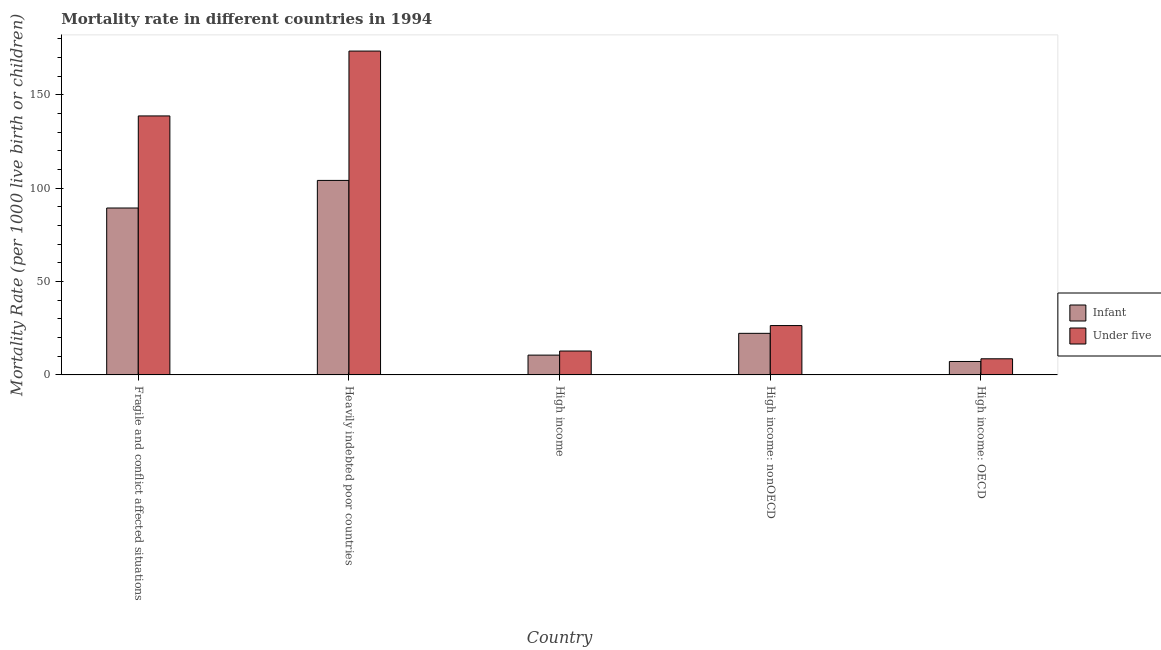How many different coloured bars are there?
Your answer should be very brief. 2. How many groups of bars are there?
Ensure brevity in your answer.  5. How many bars are there on the 2nd tick from the left?
Your answer should be very brief. 2. What is the label of the 3rd group of bars from the left?
Offer a very short reply. High income. What is the infant mortality rate in Fragile and conflict affected situations?
Provide a succinct answer. 89.4. Across all countries, what is the maximum infant mortality rate?
Keep it short and to the point. 104.19. Across all countries, what is the minimum under-5 mortality rate?
Provide a succinct answer. 8.63. In which country was the infant mortality rate maximum?
Keep it short and to the point. Heavily indebted poor countries. In which country was the under-5 mortality rate minimum?
Make the answer very short. High income: OECD. What is the total infant mortality rate in the graph?
Your response must be concise. 233.66. What is the difference between the infant mortality rate in Fragile and conflict affected situations and that in Heavily indebted poor countries?
Make the answer very short. -14.78. What is the difference between the infant mortality rate in High income: OECD and the under-5 mortality rate in High income?
Give a very brief answer. -5.61. What is the average infant mortality rate per country?
Offer a terse response. 46.73. What is the difference between the under-5 mortality rate and infant mortality rate in High income: OECD?
Your answer should be very brief. 1.44. In how many countries, is the under-5 mortality rate greater than 80 ?
Keep it short and to the point. 2. What is the ratio of the under-5 mortality rate in High income: OECD to that in High income: nonOECD?
Your answer should be very brief. 0.33. What is the difference between the highest and the second highest infant mortality rate?
Offer a terse response. 14.78. What is the difference between the highest and the lowest under-5 mortality rate?
Your answer should be very brief. 164.84. In how many countries, is the infant mortality rate greater than the average infant mortality rate taken over all countries?
Provide a succinct answer. 2. Is the sum of the infant mortality rate in Fragile and conflict affected situations and High income greater than the maximum under-5 mortality rate across all countries?
Your response must be concise. No. What does the 2nd bar from the left in High income: OECD represents?
Give a very brief answer. Under five. What does the 1st bar from the right in High income represents?
Provide a short and direct response. Under five. How many bars are there?
Give a very brief answer. 10. Are all the bars in the graph horizontal?
Your response must be concise. No. What is the difference between two consecutive major ticks on the Y-axis?
Your response must be concise. 50. Are the values on the major ticks of Y-axis written in scientific E-notation?
Your answer should be compact. No. Does the graph contain any zero values?
Your answer should be compact. No. Does the graph contain grids?
Provide a succinct answer. No. Where does the legend appear in the graph?
Make the answer very short. Center right. How many legend labels are there?
Your answer should be compact. 2. What is the title of the graph?
Provide a short and direct response. Mortality rate in different countries in 1994. What is the label or title of the X-axis?
Keep it short and to the point. Country. What is the label or title of the Y-axis?
Your response must be concise. Mortality Rate (per 1000 live birth or children). What is the Mortality Rate (per 1000 live birth or children) in Infant in Fragile and conflict affected situations?
Keep it short and to the point. 89.4. What is the Mortality Rate (per 1000 live birth or children) of Under five in Fragile and conflict affected situations?
Make the answer very short. 138.73. What is the Mortality Rate (per 1000 live birth or children) in Infant in Heavily indebted poor countries?
Provide a succinct answer. 104.19. What is the Mortality Rate (per 1000 live birth or children) of Under five in Heavily indebted poor countries?
Your answer should be very brief. 173.48. What is the Mortality Rate (per 1000 live birth or children) in Infant in High income: nonOECD?
Offer a terse response. 22.27. What is the Mortality Rate (per 1000 live birth or children) of Under five in High income: nonOECD?
Offer a very short reply. 26.43. What is the Mortality Rate (per 1000 live birth or children) of Infant in High income: OECD?
Offer a terse response. 7.19. What is the Mortality Rate (per 1000 live birth or children) in Under five in High income: OECD?
Keep it short and to the point. 8.63. Across all countries, what is the maximum Mortality Rate (per 1000 live birth or children) of Infant?
Your answer should be compact. 104.19. Across all countries, what is the maximum Mortality Rate (per 1000 live birth or children) of Under five?
Your answer should be compact. 173.48. Across all countries, what is the minimum Mortality Rate (per 1000 live birth or children) of Infant?
Your answer should be compact. 7.19. Across all countries, what is the minimum Mortality Rate (per 1000 live birth or children) of Under five?
Keep it short and to the point. 8.63. What is the total Mortality Rate (per 1000 live birth or children) in Infant in the graph?
Offer a terse response. 233.66. What is the total Mortality Rate (per 1000 live birth or children) of Under five in the graph?
Ensure brevity in your answer.  360.07. What is the difference between the Mortality Rate (per 1000 live birth or children) of Infant in Fragile and conflict affected situations and that in Heavily indebted poor countries?
Provide a short and direct response. -14.78. What is the difference between the Mortality Rate (per 1000 live birth or children) of Under five in Fragile and conflict affected situations and that in Heavily indebted poor countries?
Your response must be concise. -34.75. What is the difference between the Mortality Rate (per 1000 live birth or children) in Infant in Fragile and conflict affected situations and that in High income?
Provide a succinct answer. 78.8. What is the difference between the Mortality Rate (per 1000 live birth or children) of Under five in Fragile and conflict affected situations and that in High income?
Ensure brevity in your answer.  125.93. What is the difference between the Mortality Rate (per 1000 live birth or children) in Infant in Fragile and conflict affected situations and that in High income: nonOECD?
Your response must be concise. 67.13. What is the difference between the Mortality Rate (per 1000 live birth or children) in Under five in Fragile and conflict affected situations and that in High income: nonOECD?
Your response must be concise. 112.3. What is the difference between the Mortality Rate (per 1000 live birth or children) in Infant in Fragile and conflict affected situations and that in High income: OECD?
Provide a short and direct response. 82.21. What is the difference between the Mortality Rate (per 1000 live birth or children) of Under five in Fragile and conflict affected situations and that in High income: OECD?
Your response must be concise. 130.09. What is the difference between the Mortality Rate (per 1000 live birth or children) in Infant in Heavily indebted poor countries and that in High income?
Your answer should be very brief. 93.59. What is the difference between the Mortality Rate (per 1000 live birth or children) of Under five in Heavily indebted poor countries and that in High income?
Ensure brevity in your answer.  160.68. What is the difference between the Mortality Rate (per 1000 live birth or children) in Infant in Heavily indebted poor countries and that in High income: nonOECD?
Keep it short and to the point. 81.92. What is the difference between the Mortality Rate (per 1000 live birth or children) in Under five in Heavily indebted poor countries and that in High income: nonOECD?
Offer a terse response. 147.05. What is the difference between the Mortality Rate (per 1000 live birth or children) in Infant in Heavily indebted poor countries and that in High income: OECD?
Offer a very short reply. 96.99. What is the difference between the Mortality Rate (per 1000 live birth or children) of Under five in Heavily indebted poor countries and that in High income: OECD?
Your answer should be very brief. 164.84. What is the difference between the Mortality Rate (per 1000 live birth or children) of Infant in High income and that in High income: nonOECD?
Provide a succinct answer. -11.67. What is the difference between the Mortality Rate (per 1000 live birth or children) of Under five in High income and that in High income: nonOECD?
Provide a short and direct response. -13.63. What is the difference between the Mortality Rate (per 1000 live birth or children) of Infant in High income and that in High income: OECD?
Provide a succinct answer. 3.41. What is the difference between the Mortality Rate (per 1000 live birth or children) in Under five in High income and that in High income: OECD?
Your answer should be compact. 4.17. What is the difference between the Mortality Rate (per 1000 live birth or children) in Infant in High income: nonOECD and that in High income: OECD?
Give a very brief answer. 15.08. What is the difference between the Mortality Rate (per 1000 live birth or children) of Under five in High income: nonOECD and that in High income: OECD?
Provide a short and direct response. 17.8. What is the difference between the Mortality Rate (per 1000 live birth or children) in Infant in Fragile and conflict affected situations and the Mortality Rate (per 1000 live birth or children) in Under five in Heavily indebted poor countries?
Keep it short and to the point. -84.07. What is the difference between the Mortality Rate (per 1000 live birth or children) of Infant in Fragile and conflict affected situations and the Mortality Rate (per 1000 live birth or children) of Under five in High income?
Your answer should be very brief. 76.6. What is the difference between the Mortality Rate (per 1000 live birth or children) in Infant in Fragile and conflict affected situations and the Mortality Rate (per 1000 live birth or children) in Under five in High income: nonOECD?
Keep it short and to the point. 62.97. What is the difference between the Mortality Rate (per 1000 live birth or children) of Infant in Fragile and conflict affected situations and the Mortality Rate (per 1000 live birth or children) of Under five in High income: OECD?
Your response must be concise. 80.77. What is the difference between the Mortality Rate (per 1000 live birth or children) in Infant in Heavily indebted poor countries and the Mortality Rate (per 1000 live birth or children) in Under five in High income?
Your answer should be compact. 91.39. What is the difference between the Mortality Rate (per 1000 live birth or children) of Infant in Heavily indebted poor countries and the Mortality Rate (per 1000 live birth or children) of Under five in High income: nonOECD?
Make the answer very short. 77.76. What is the difference between the Mortality Rate (per 1000 live birth or children) in Infant in Heavily indebted poor countries and the Mortality Rate (per 1000 live birth or children) in Under five in High income: OECD?
Make the answer very short. 95.55. What is the difference between the Mortality Rate (per 1000 live birth or children) of Infant in High income and the Mortality Rate (per 1000 live birth or children) of Under five in High income: nonOECD?
Your response must be concise. -15.83. What is the difference between the Mortality Rate (per 1000 live birth or children) of Infant in High income and the Mortality Rate (per 1000 live birth or children) of Under five in High income: OECD?
Your response must be concise. 1.97. What is the difference between the Mortality Rate (per 1000 live birth or children) of Infant in High income: nonOECD and the Mortality Rate (per 1000 live birth or children) of Under five in High income: OECD?
Provide a short and direct response. 13.64. What is the average Mortality Rate (per 1000 live birth or children) in Infant per country?
Ensure brevity in your answer.  46.73. What is the average Mortality Rate (per 1000 live birth or children) in Under five per country?
Keep it short and to the point. 72.01. What is the difference between the Mortality Rate (per 1000 live birth or children) in Infant and Mortality Rate (per 1000 live birth or children) in Under five in Fragile and conflict affected situations?
Offer a terse response. -49.32. What is the difference between the Mortality Rate (per 1000 live birth or children) of Infant and Mortality Rate (per 1000 live birth or children) of Under five in Heavily indebted poor countries?
Provide a succinct answer. -69.29. What is the difference between the Mortality Rate (per 1000 live birth or children) in Infant and Mortality Rate (per 1000 live birth or children) in Under five in High income: nonOECD?
Keep it short and to the point. -4.16. What is the difference between the Mortality Rate (per 1000 live birth or children) in Infant and Mortality Rate (per 1000 live birth or children) in Under five in High income: OECD?
Ensure brevity in your answer.  -1.44. What is the ratio of the Mortality Rate (per 1000 live birth or children) of Infant in Fragile and conflict affected situations to that in Heavily indebted poor countries?
Your answer should be compact. 0.86. What is the ratio of the Mortality Rate (per 1000 live birth or children) of Under five in Fragile and conflict affected situations to that in Heavily indebted poor countries?
Give a very brief answer. 0.8. What is the ratio of the Mortality Rate (per 1000 live birth or children) in Infant in Fragile and conflict affected situations to that in High income?
Keep it short and to the point. 8.43. What is the ratio of the Mortality Rate (per 1000 live birth or children) in Under five in Fragile and conflict affected situations to that in High income?
Give a very brief answer. 10.84. What is the ratio of the Mortality Rate (per 1000 live birth or children) of Infant in Fragile and conflict affected situations to that in High income: nonOECD?
Ensure brevity in your answer.  4.01. What is the ratio of the Mortality Rate (per 1000 live birth or children) of Under five in Fragile and conflict affected situations to that in High income: nonOECD?
Your answer should be very brief. 5.25. What is the ratio of the Mortality Rate (per 1000 live birth or children) of Infant in Fragile and conflict affected situations to that in High income: OECD?
Keep it short and to the point. 12.43. What is the ratio of the Mortality Rate (per 1000 live birth or children) of Under five in Fragile and conflict affected situations to that in High income: OECD?
Your answer should be compact. 16.07. What is the ratio of the Mortality Rate (per 1000 live birth or children) in Infant in Heavily indebted poor countries to that in High income?
Offer a terse response. 9.83. What is the ratio of the Mortality Rate (per 1000 live birth or children) in Under five in Heavily indebted poor countries to that in High income?
Ensure brevity in your answer.  13.55. What is the ratio of the Mortality Rate (per 1000 live birth or children) in Infant in Heavily indebted poor countries to that in High income: nonOECD?
Your answer should be very brief. 4.68. What is the ratio of the Mortality Rate (per 1000 live birth or children) in Under five in Heavily indebted poor countries to that in High income: nonOECD?
Provide a succinct answer. 6.56. What is the ratio of the Mortality Rate (per 1000 live birth or children) in Infant in Heavily indebted poor countries to that in High income: OECD?
Keep it short and to the point. 14.48. What is the ratio of the Mortality Rate (per 1000 live birth or children) of Under five in Heavily indebted poor countries to that in High income: OECD?
Give a very brief answer. 20.09. What is the ratio of the Mortality Rate (per 1000 live birth or children) of Infant in High income to that in High income: nonOECD?
Your answer should be compact. 0.48. What is the ratio of the Mortality Rate (per 1000 live birth or children) in Under five in High income to that in High income: nonOECD?
Provide a short and direct response. 0.48. What is the ratio of the Mortality Rate (per 1000 live birth or children) of Infant in High income to that in High income: OECD?
Ensure brevity in your answer.  1.47. What is the ratio of the Mortality Rate (per 1000 live birth or children) in Under five in High income to that in High income: OECD?
Your answer should be very brief. 1.48. What is the ratio of the Mortality Rate (per 1000 live birth or children) in Infant in High income: nonOECD to that in High income: OECD?
Offer a very short reply. 3.1. What is the ratio of the Mortality Rate (per 1000 live birth or children) of Under five in High income: nonOECD to that in High income: OECD?
Offer a terse response. 3.06. What is the difference between the highest and the second highest Mortality Rate (per 1000 live birth or children) in Infant?
Make the answer very short. 14.78. What is the difference between the highest and the second highest Mortality Rate (per 1000 live birth or children) of Under five?
Offer a terse response. 34.75. What is the difference between the highest and the lowest Mortality Rate (per 1000 live birth or children) in Infant?
Provide a succinct answer. 96.99. What is the difference between the highest and the lowest Mortality Rate (per 1000 live birth or children) in Under five?
Your answer should be compact. 164.84. 